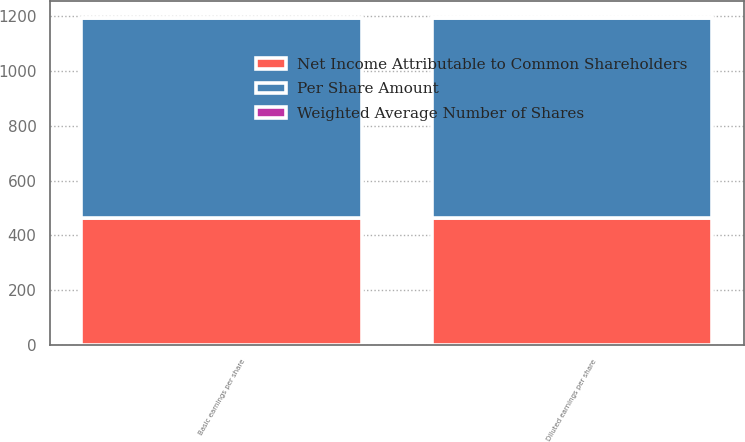Convert chart to OTSL. <chart><loc_0><loc_0><loc_500><loc_500><stacked_bar_chart><ecel><fcel>Basic earnings per share<fcel>Diluted earnings per share<nl><fcel>Per Share Amount<fcel>729.7<fcel>729.7<nl><fcel>Net Income Attributable to Common Shareholders<fcel>462.9<fcel>464.7<nl><fcel>Weighted Average Number of Shares<fcel>1.58<fcel>1.57<nl></chart> 